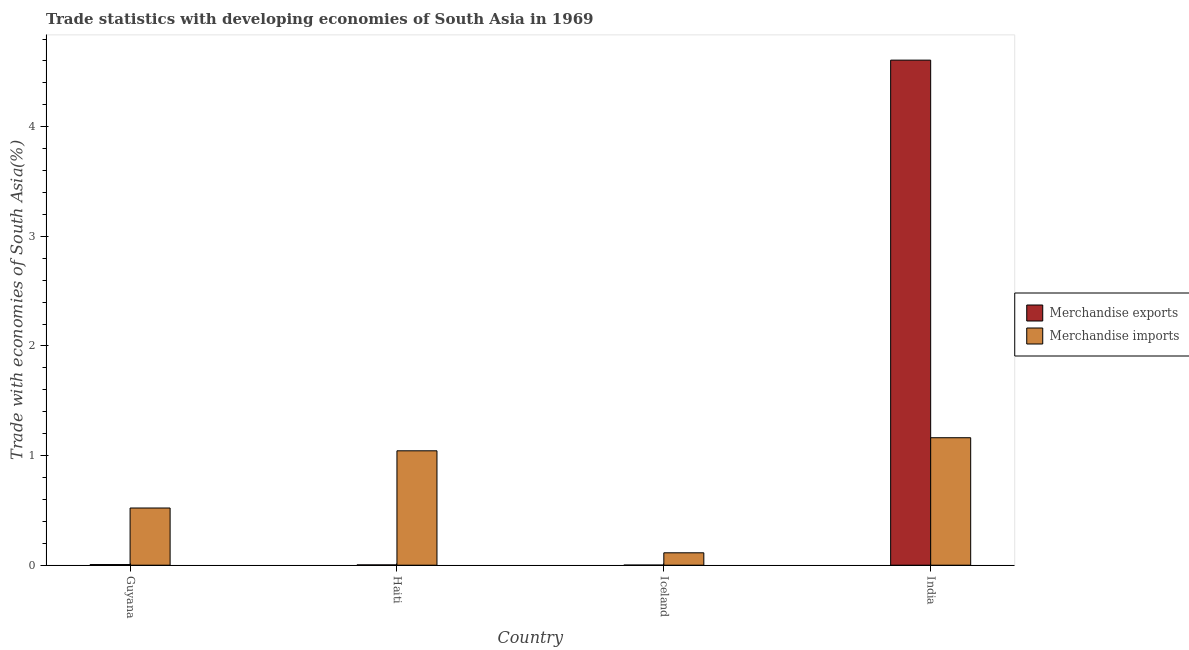How many groups of bars are there?
Give a very brief answer. 4. Are the number of bars per tick equal to the number of legend labels?
Your answer should be compact. Yes. How many bars are there on the 4th tick from the left?
Give a very brief answer. 2. What is the label of the 2nd group of bars from the left?
Your answer should be very brief. Haiti. In how many cases, is the number of bars for a given country not equal to the number of legend labels?
Provide a short and direct response. 0. What is the merchandise imports in Guyana?
Your response must be concise. 0.52. Across all countries, what is the maximum merchandise imports?
Your answer should be compact. 1.16. Across all countries, what is the minimum merchandise exports?
Offer a very short reply. 0. In which country was the merchandise exports maximum?
Provide a succinct answer. India. What is the total merchandise imports in the graph?
Keep it short and to the point. 2.84. What is the difference between the merchandise exports in Guyana and that in India?
Your answer should be very brief. -4.6. What is the difference between the merchandise imports in Haiti and the merchandise exports in Iceland?
Offer a terse response. 1.04. What is the average merchandise imports per country?
Offer a very short reply. 0.71. What is the difference between the merchandise exports and merchandise imports in Haiti?
Give a very brief answer. -1.04. In how many countries, is the merchandise imports greater than 0.2 %?
Ensure brevity in your answer.  3. What is the ratio of the merchandise exports in Haiti to that in India?
Provide a short and direct response. 0. Is the merchandise imports in Guyana less than that in Haiti?
Your answer should be compact. Yes. Is the difference between the merchandise imports in Haiti and Iceland greater than the difference between the merchandise exports in Haiti and Iceland?
Ensure brevity in your answer.  Yes. What is the difference between the highest and the second highest merchandise exports?
Give a very brief answer. 4.6. What is the difference between the highest and the lowest merchandise exports?
Provide a short and direct response. 4.61. Is the sum of the merchandise exports in Iceland and India greater than the maximum merchandise imports across all countries?
Offer a terse response. Yes. Are all the bars in the graph horizontal?
Keep it short and to the point. No. Does the graph contain grids?
Ensure brevity in your answer.  No. Where does the legend appear in the graph?
Provide a succinct answer. Center right. How many legend labels are there?
Ensure brevity in your answer.  2. What is the title of the graph?
Ensure brevity in your answer.  Trade statistics with developing economies of South Asia in 1969. What is the label or title of the Y-axis?
Your response must be concise. Trade with economies of South Asia(%). What is the Trade with economies of South Asia(%) of Merchandise exports in Guyana?
Provide a short and direct response. 0.01. What is the Trade with economies of South Asia(%) in Merchandise imports in Guyana?
Offer a terse response. 0.52. What is the Trade with economies of South Asia(%) in Merchandise exports in Haiti?
Give a very brief answer. 0. What is the Trade with economies of South Asia(%) of Merchandise imports in Haiti?
Give a very brief answer. 1.04. What is the Trade with economies of South Asia(%) of Merchandise exports in Iceland?
Offer a terse response. 0. What is the Trade with economies of South Asia(%) of Merchandise imports in Iceland?
Offer a terse response. 0.11. What is the Trade with economies of South Asia(%) of Merchandise exports in India?
Provide a succinct answer. 4.61. What is the Trade with economies of South Asia(%) of Merchandise imports in India?
Provide a short and direct response. 1.16. Across all countries, what is the maximum Trade with economies of South Asia(%) of Merchandise exports?
Provide a succinct answer. 4.61. Across all countries, what is the maximum Trade with economies of South Asia(%) in Merchandise imports?
Provide a short and direct response. 1.16. Across all countries, what is the minimum Trade with economies of South Asia(%) in Merchandise exports?
Your response must be concise. 0. Across all countries, what is the minimum Trade with economies of South Asia(%) of Merchandise imports?
Your response must be concise. 0.11. What is the total Trade with economies of South Asia(%) in Merchandise exports in the graph?
Offer a very short reply. 4.62. What is the total Trade with economies of South Asia(%) in Merchandise imports in the graph?
Ensure brevity in your answer.  2.84. What is the difference between the Trade with economies of South Asia(%) of Merchandise exports in Guyana and that in Haiti?
Your response must be concise. 0. What is the difference between the Trade with economies of South Asia(%) in Merchandise imports in Guyana and that in Haiti?
Give a very brief answer. -0.52. What is the difference between the Trade with economies of South Asia(%) of Merchandise exports in Guyana and that in Iceland?
Provide a short and direct response. 0. What is the difference between the Trade with economies of South Asia(%) in Merchandise imports in Guyana and that in Iceland?
Offer a terse response. 0.41. What is the difference between the Trade with economies of South Asia(%) of Merchandise exports in Guyana and that in India?
Make the answer very short. -4.6. What is the difference between the Trade with economies of South Asia(%) of Merchandise imports in Guyana and that in India?
Your response must be concise. -0.64. What is the difference between the Trade with economies of South Asia(%) of Merchandise exports in Haiti and that in Iceland?
Ensure brevity in your answer.  0. What is the difference between the Trade with economies of South Asia(%) of Merchandise imports in Haiti and that in Iceland?
Provide a short and direct response. 0.93. What is the difference between the Trade with economies of South Asia(%) in Merchandise exports in Haiti and that in India?
Your response must be concise. -4.6. What is the difference between the Trade with economies of South Asia(%) in Merchandise imports in Haiti and that in India?
Provide a succinct answer. -0.12. What is the difference between the Trade with economies of South Asia(%) of Merchandise exports in Iceland and that in India?
Provide a succinct answer. -4.61. What is the difference between the Trade with economies of South Asia(%) of Merchandise imports in Iceland and that in India?
Ensure brevity in your answer.  -1.05. What is the difference between the Trade with economies of South Asia(%) in Merchandise exports in Guyana and the Trade with economies of South Asia(%) in Merchandise imports in Haiti?
Ensure brevity in your answer.  -1.04. What is the difference between the Trade with economies of South Asia(%) in Merchandise exports in Guyana and the Trade with economies of South Asia(%) in Merchandise imports in Iceland?
Give a very brief answer. -0.11. What is the difference between the Trade with economies of South Asia(%) of Merchandise exports in Guyana and the Trade with economies of South Asia(%) of Merchandise imports in India?
Your answer should be compact. -1.16. What is the difference between the Trade with economies of South Asia(%) of Merchandise exports in Haiti and the Trade with economies of South Asia(%) of Merchandise imports in Iceland?
Offer a terse response. -0.11. What is the difference between the Trade with economies of South Asia(%) in Merchandise exports in Haiti and the Trade with economies of South Asia(%) in Merchandise imports in India?
Ensure brevity in your answer.  -1.16. What is the difference between the Trade with economies of South Asia(%) of Merchandise exports in Iceland and the Trade with economies of South Asia(%) of Merchandise imports in India?
Offer a terse response. -1.16. What is the average Trade with economies of South Asia(%) in Merchandise exports per country?
Your response must be concise. 1.15. What is the average Trade with economies of South Asia(%) of Merchandise imports per country?
Your answer should be very brief. 0.71. What is the difference between the Trade with economies of South Asia(%) in Merchandise exports and Trade with economies of South Asia(%) in Merchandise imports in Guyana?
Your answer should be very brief. -0.52. What is the difference between the Trade with economies of South Asia(%) in Merchandise exports and Trade with economies of South Asia(%) in Merchandise imports in Haiti?
Your answer should be very brief. -1.04. What is the difference between the Trade with economies of South Asia(%) of Merchandise exports and Trade with economies of South Asia(%) of Merchandise imports in Iceland?
Make the answer very short. -0.11. What is the difference between the Trade with economies of South Asia(%) of Merchandise exports and Trade with economies of South Asia(%) of Merchandise imports in India?
Keep it short and to the point. 3.44. What is the ratio of the Trade with economies of South Asia(%) of Merchandise exports in Guyana to that in Haiti?
Provide a succinct answer. 2.16. What is the ratio of the Trade with economies of South Asia(%) in Merchandise imports in Guyana to that in Haiti?
Keep it short and to the point. 0.5. What is the ratio of the Trade with economies of South Asia(%) in Merchandise exports in Guyana to that in Iceland?
Keep it short and to the point. 6.28. What is the ratio of the Trade with economies of South Asia(%) in Merchandise imports in Guyana to that in Iceland?
Your answer should be compact. 4.61. What is the ratio of the Trade with economies of South Asia(%) in Merchandise exports in Guyana to that in India?
Give a very brief answer. 0. What is the ratio of the Trade with economies of South Asia(%) in Merchandise imports in Guyana to that in India?
Ensure brevity in your answer.  0.45. What is the ratio of the Trade with economies of South Asia(%) in Merchandise exports in Haiti to that in Iceland?
Your answer should be very brief. 2.9. What is the ratio of the Trade with economies of South Asia(%) of Merchandise imports in Haiti to that in Iceland?
Provide a short and direct response. 9.23. What is the ratio of the Trade with economies of South Asia(%) of Merchandise exports in Haiti to that in India?
Ensure brevity in your answer.  0. What is the ratio of the Trade with economies of South Asia(%) of Merchandise imports in Haiti to that in India?
Your answer should be compact. 0.9. What is the ratio of the Trade with economies of South Asia(%) in Merchandise imports in Iceland to that in India?
Make the answer very short. 0.1. What is the difference between the highest and the second highest Trade with economies of South Asia(%) of Merchandise exports?
Give a very brief answer. 4.6. What is the difference between the highest and the second highest Trade with economies of South Asia(%) in Merchandise imports?
Provide a short and direct response. 0.12. What is the difference between the highest and the lowest Trade with economies of South Asia(%) in Merchandise exports?
Offer a terse response. 4.61. What is the difference between the highest and the lowest Trade with economies of South Asia(%) in Merchandise imports?
Your answer should be very brief. 1.05. 